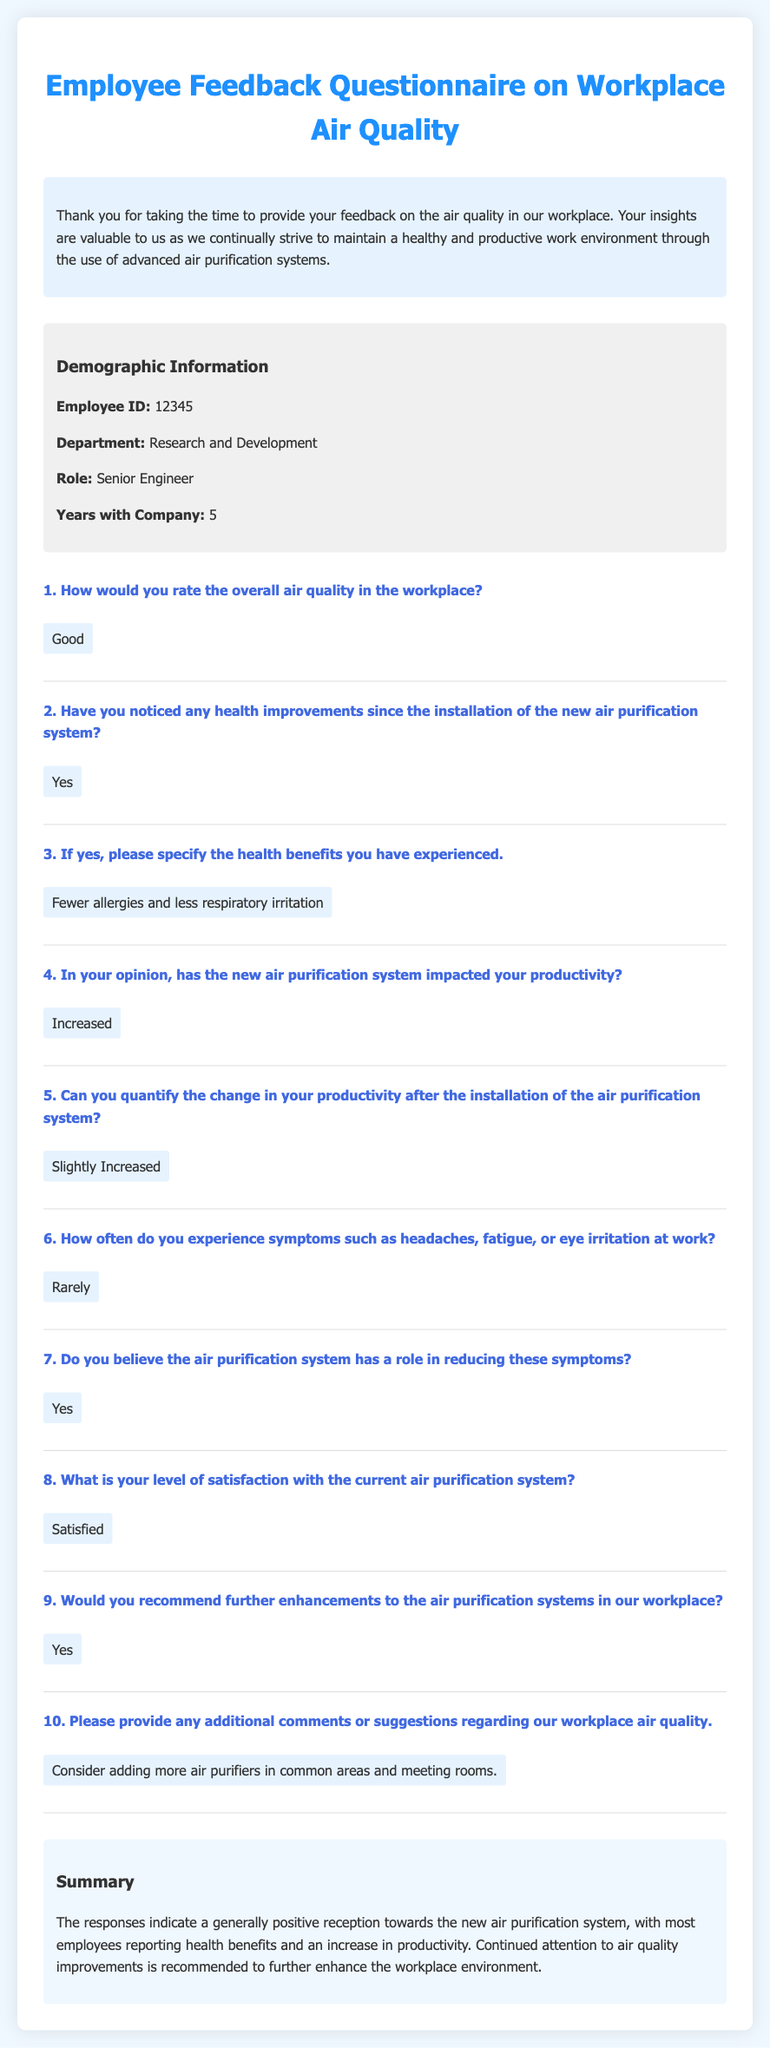What is the employee ID? The employee ID is clearly stated in the demographic information section of the document.
Answer: 12345 What department does the employee belong to? The document specifies the department in the demographic information section.
Answer: Research and Development How many years has the employee been with the company? The number of years with the company is listed in the demographic information section of the document.
Answer: 5 What is the overall rating of the air quality in the workplace? The overall air quality rating is given in response to the first question on air quality.
Answer: Good What health improvement has the employee noticed? The document notes specific health benefits experienced by the employee since the installation of the air purification system.
Answer: Fewer allergies and less respiratory irritation How often does the employee experience headaches at work? The frequency of symptoms like headaches is asked in question six, providing insight into employee health experiences.
Answer: Rarely What is the employee's level of satisfaction with the air purification system? The level of satisfaction with the air purification system is specified in response to question eight.
Answer: Satisfied Does the employee believe in further enhancements for air purification systems? The employee's belief in further enhancements is addressed in the response to question nine.
Answer: Yes 